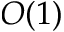Convert formula to latex. <formula><loc_0><loc_0><loc_500><loc_500>O ( 1 )</formula> 